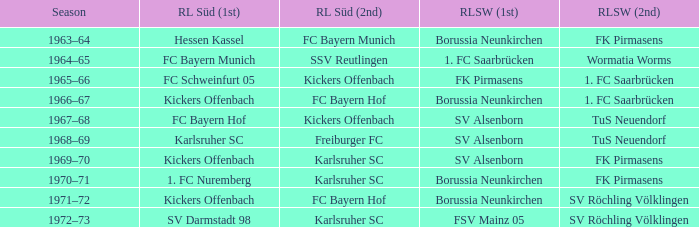What season was Freiburger FC the RL Süd (2nd) team? 1968–69. Parse the full table. {'header': ['Season', 'RL Süd (1st)', 'RL Süd (2nd)', 'RLSW (1st)', 'RLSW (2nd)'], 'rows': [['1963–64', 'Hessen Kassel', 'FC Bayern Munich', 'Borussia Neunkirchen', 'FK Pirmasens'], ['1964–65', 'FC Bayern Munich', 'SSV Reutlingen', '1. FC Saarbrücken', 'Wormatia Worms'], ['1965–66', 'FC Schweinfurt 05', 'Kickers Offenbach', 'FK Pirmasens', '1. FC Saarbrücken'], ['1966–67', 'Kickers Offenbach', 'FC Bayern Hof', 'Borussia Neunkirchen', '1. FC Saarbrücken'], ['1967–68', 'FC Bayern Hof', 'Kickers Offenbach', 'SV Alsenborn', 'TuS Neuendorf'], ['1968–69', 'Karlsruher SC', 'Freiburger FC', 'SV Alsenborn', 'TuS Neuendorf'], ['1969–70', 'Kickers Offenbach', 'Karlsruher SC', 'SV Alsenborn', 'FK Pirmasens'], ['1970–71', '1. FC Nuremberg', 'Karlsruher SC', 'Borussia Neunkirchen', 'FK Pirmasens'], ['1971–72', 'Kickers Offenbach', 'FC Bayern Hof', 'Borussia Neunkirchen', 'SV Röchling Völklingen'], ['1972–73', 'SV Darmstadt 98', 'Karlsruher SC', 'FSV Mainz 05', 'SV Röchling Völklingen']]} 